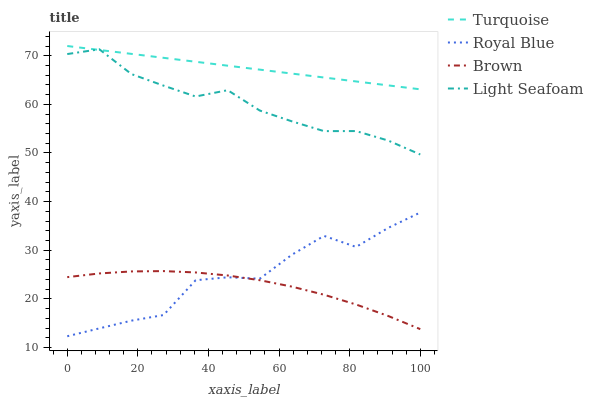Does Brown have the minimum area under the curve?
Answer yes or no. Yes. Does Turquoise have the maximum area under the curve?
Answer yes or no. Yes. Does Light Seafoam have the minimum area under the curve?
Answer yes or no. No. Does Light Seafoam have the maximum area under the curve?
Answer yes or no. No. Is Turquoise the smoothest?
Answer yes or no. Yes. Is Royal Blue the roughest?
Answer yes or no. Yes. Is Light Seafoam the smoothest?
Answer yes or no. No. Is Light Seafoam the roughest?
Answer yes or no. No. Does Royal Blue have the lowest value?
Answer yes or no. Yes. Does Light Seafoam have the lowest value?
Answer yes or no. No. Does Turquoise have the highest value?
Answer yes or no. Yes. Does Light Seafoam have the highest value?
Answer yes or no. No. Is Brown less than Turquoise?
Answer yes or no. Yes. Is Turquoise greater than Brown?
Answer yes or no. Yes. Does Turquoise intersect Light Seafoam?
Answer yes or no. Yes. Is Turquoise less than Light Seafoam?
Answer yes or no. No. Is Turquoise greater than Light Seafoam?
Answer yes or no. No. Does Brown intersect Turquoise?
Answer yes or no. No. 